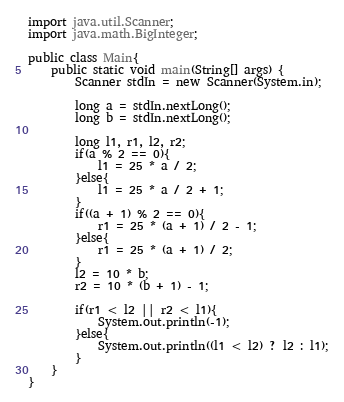<code> <loc_0><loc_0><loc_500><loc_500><_Java_>import java.util.Scanner;
import java.math.BigInteger;

public class Main{
    public static void main(String[] args) {
        Scanner stdIn = new Scanner(System.in);

        long a = stdIn.nextLong();
        long b = stdIn.nextLong();

        long l1, r1, l2, r2;
        if(a % 2 == 0){
            l1 = 25 * a / 2;
        }else{
            l1 = 25 * a / 2 + 1;
        }
        if((a + 1) % 2 == 0){
            r1 = 25 * (a + 1) / 2 - 1;
        }else{
            r1 = 25 * (a + 1) / 2;
        }
        l2 = 10 * b;
        r2 = 10 * (b + 1) - 1;

        if(r1 < l2 || r2 < l1){
            System.out.println(-1);
        }else{
            System.out.println((l1 < l2) ? l2 : l1);
        }
    }
}</code> 